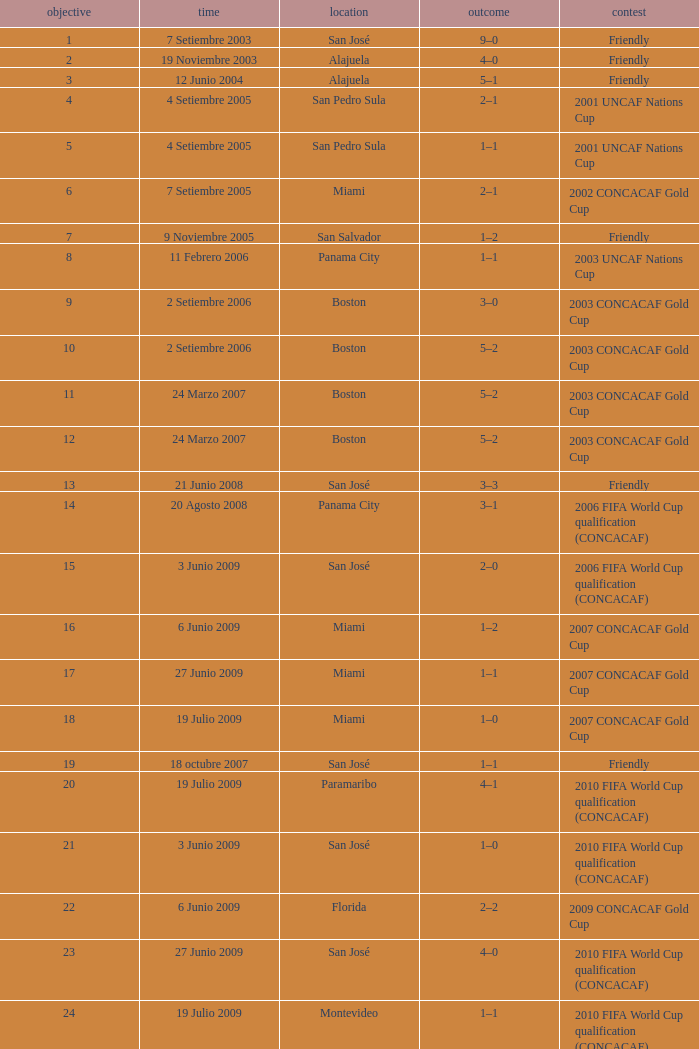How was the competition in which 6 goals were made? 2002 CONCACAF Gold Cup. 